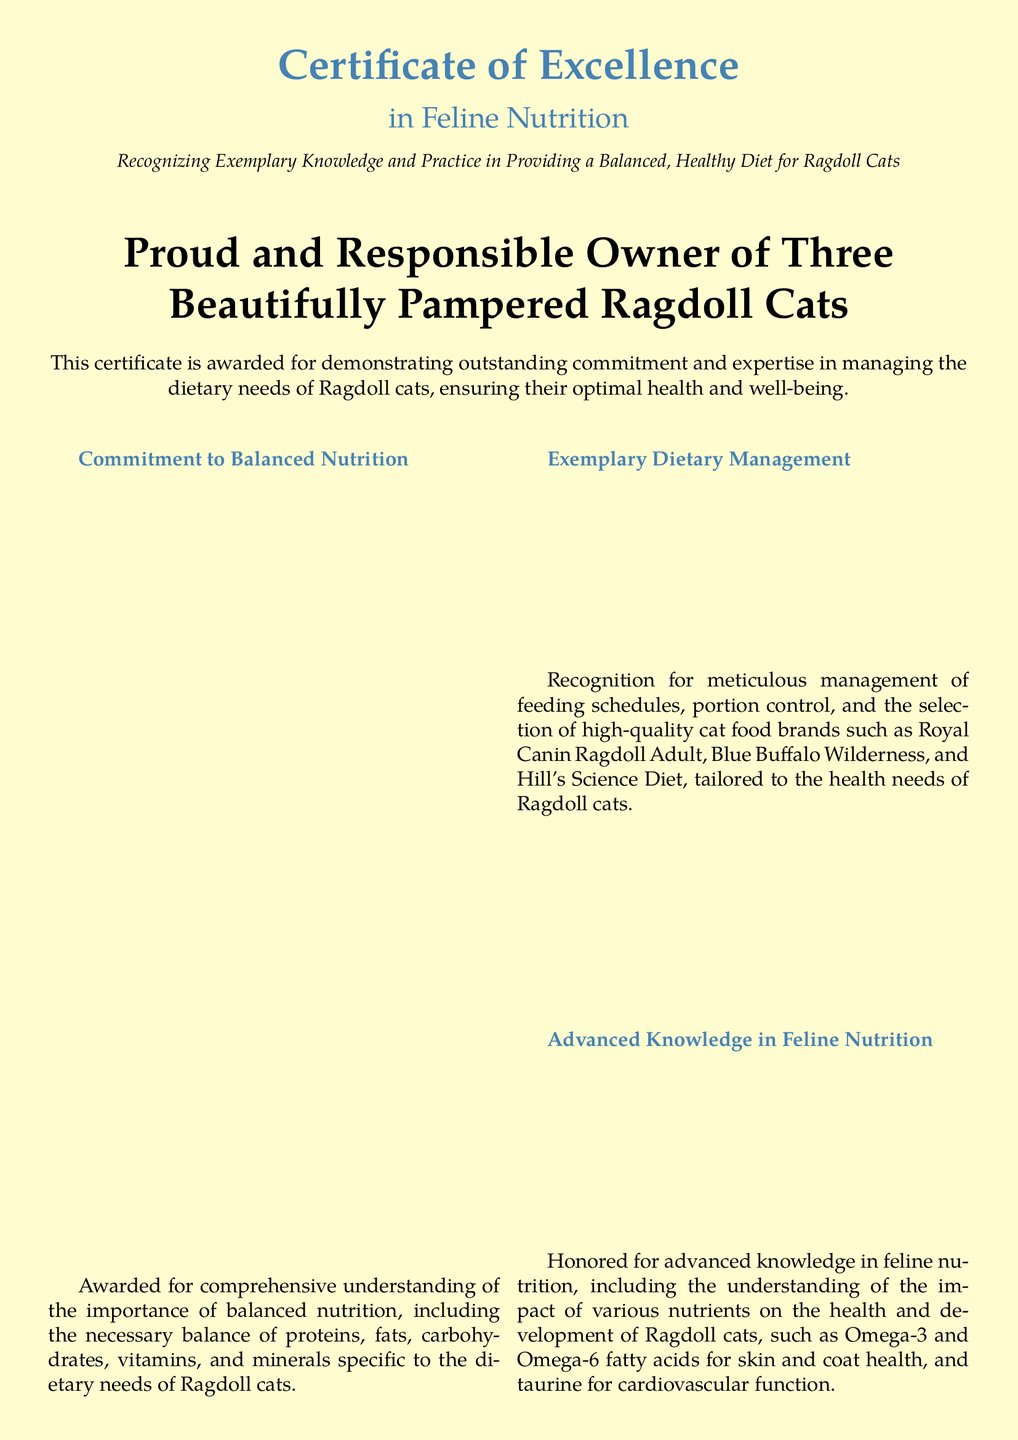What is the title of the certificate? The title of the certificate is prominently displayed in large font at the top of the document.
Answer: Certificate of Excellence Who is the certificate awarded to? The awarded individual is mentioned in a clear, large font in the center of the document.
Answer: Proud and Responsible Owner of Three Beautifully Pampered Ragdoll Cats What is the main focus of this certificate? The certificate recognizes knowledge and practice in a specific area related to cat care.
Answer: Feline Nutrition What organization issued the certificate? The issuing organization is noted at the bottom of the document.
Answer: Ragdoll Cat Enthusiasts Association What type of nutritional balance is emphasized in the certificate? The document mentions specific dietary components that need to be balanced for Ragdoll cats.
Answer: Proteins, fats, carbohydrates, vitamins, and minerals What quality cat food brands are mentioned in the certificate? The document lists specific brands of cat food associated with Ragdoll cats.
Answer: Royal Canin Ragdoll Adult, Blue Buffalo Wilderness, Hill's Science Diet What is acknowledged under "Health Monitoring and Adjustments"? This section highlights the proactive actions taken for dietary needs addressing specific health issues.
Answer: Food sensitivities, allergies, obesity, digestive issues What is the importance of Omega-3 and Omega-6 fatty acids mentioned in the certificate? These nutrients are specifically noted for their benefits on health-related aspects of Ragdoll cats.
Answer: Skin and coat health 